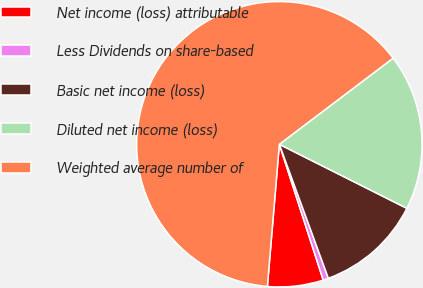Convert chart. <chart><loc_0><loc_0><loc_500><loc_500><pie_chart><fcel>Net income (loss) attributable<fcel>Less Dividends on share-based<fcel>Basic net income (loss)<fcel>Diluted net income (loss)<fcel>Weighted average number of<nl><fcel>6.31%<fcel>0.61%<fcel>12.01%<fcel>17.72%<fcel>63.35%<nl></chart> 